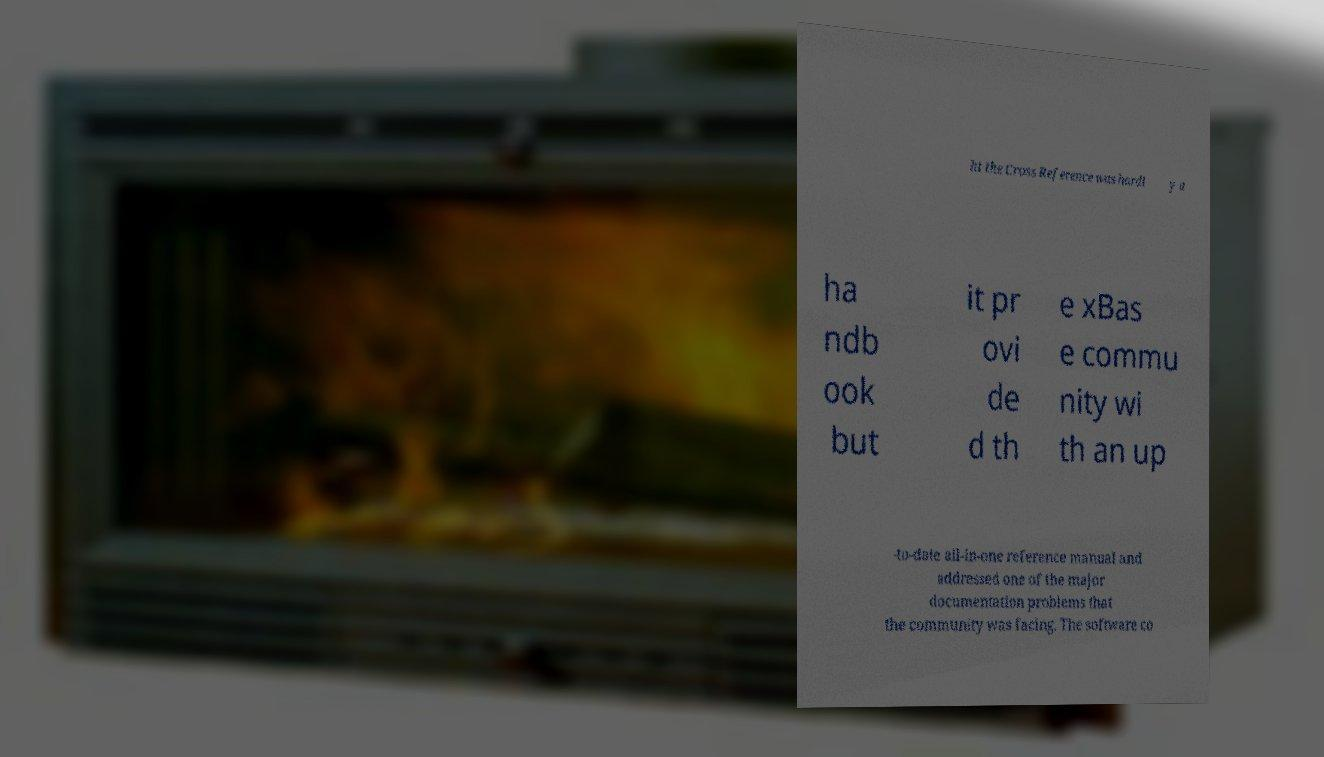Please read and relay the text visible in this image. What does it say? ht the Cross Reference was hardl y a ha ndb ook but it pr ovi de d th e xBas e commu nity wi th an up -to-date all-in-one reference manual and addressed one of the major documentation problems that the community was facing. The software co 